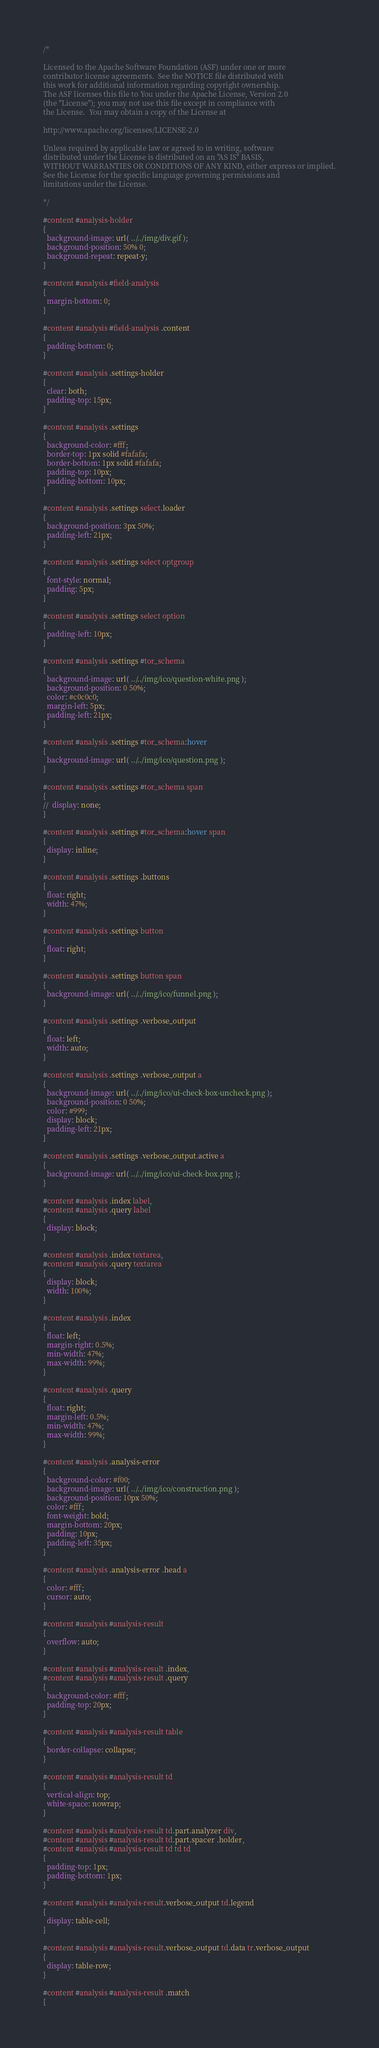<code> <loc_0><loc_0><loc_500><loc_500><_CSS_>/*

Licensed to the Apache Software Foundation (ASF) under one or more
contributor license agreements.  See the NOTICE file distributed with
this work for additional information regarding copyright ownership.
The ASF licenses this file to You under the Apache License, Version 2.0
(the "License"); you may not use this file except in compliance with
the License.  You may obtain a copy of the License at

http://www.apache.org/licenses/LICENSE-2.0

Unless required by applicable law or agreed to in writing, software
distributed under the License is distributed on an "AS IS" BASIS,
WITHOUT WARRANTIES OR CONDITIONS OF ANY KIND, either express or implied.
See the License for the specific language governing permissions and
limitations under the License.

*/

#content #analysis-holder
{
  background-image: url( ../../img/div.gif );
  background-position: 50% 0;
  background-repeat: repeat-y;
}

#content #analysis #field-analysis
{
  margin-bottom: 0;
}

#content #analysis #field-analysis .content
{
  padding-bottom: 0;
}

#content #analysis .settings-holder
{
  clear: both;
  padding-top: 15px;
}

#content #analysis .settings
{
  background-color: #fff;
  border-top: 1px solid #fafafa;
  border-bottom: 1px solid #fafafa;
  padding-top: 10px;
  padding-bottom: 10px;
}

#content #analysis .settings select.loader
{
  background-position: 3px 50%;
  padding-left: 21px;
}

#content #analysis .settings select optgroup
{
  font-style: normal;
  padding: 5px;
}

#content #analysis .settings select option
{
  padding-left: 10px;
}

#content #analysis .settings #tor_schema
{
  background-image: url( ../../img/ico/question-white.png );
  background-position: 0 50%;
  color: #c0c0c0;
  margin-left: 5px;
  padding-left: 21px;
}

#content #analysis .settings #tor_schema:hover
{
  background-image: url( ../../img/ico/question.png );
}

#content #analysis .settings #tor_schema span
{
//  display: none;
}

#content #analysis .settings #tor_schema:hover span
{
  display: inline;
}

#content #analysis .settings .buttons
{
  float: right;
  width: 47%;
}

#content #analysis .settings button
{
  float: right;
}

#content #analysis .settings button span
{
  background-image: url( ../../img/ico/funnel.png );
}

#content #analysis .settings .verbose_output
{
  float: left;
  width: auto;
}

#content #analysis .settings .verbose_output a
{
  background-image: url( ../../img/ico/ui-check-box-uncheck.png );
  background-position: 0 50%;
  color: #999;
  display: block;
  padding-left: 21px;
}

#content #analysis .settings .verbose_output.active a
{
  background-image: url( ../../img/ico/ui-check-box.png );
}

#content #analysis .index label,
#content #analysis .query label
{
  display: block;
}

#content #analysis .index textarea,
#content #analysis .query textarea
{
  display: block;
  width: 100%;
}

#content #analysis .index
{
  float: left;
  margin-right: 0.5%;
  min-width: 47%;
  max-width: 99%;
}

#content #analysis .query
{
  float: right;
  margin-left: 0.5%;
  min-width: 47%;
  max-width: 99%;
}

#content #analysis .analysis-error
{
  background-color: #f00;
  background-image: url( ../../img/ico/construction.png );
  background-position: 10px 50%;
  color: #fff;
  font-weight: bold;
  margin-bottom: 20px;
  padding: 10px;
  padding-left: 35px;
}

#content #analysis .analysis-error .head a
{
  color: #fff;
  cursor: auto;
}

#content #analysis #analysis-result
{
  overflow: auto;
}

#content #analysis #analysis-result .index,
#content #analysis #analysis-result .query
{
  background-color: #fff;
  padding-top: 20px;
}

#content #analysis #analysis-result table
{
  border-collapse: collapse;
}

#content #analysis #analysis-result td
{
  vertical-align: top;
  white-space: nowrap;
}

#content #analysis #analysis-result td.part.analyzer div,
#content #analysis #analysis-result td.part.spacer .holder,
#content #analysis #analysis-result td td td
{
  padding-top: 1px;
  padding-bottom: 1px;
}

#content #analysis #analysis-result.verbose_output td.legend
{
  display: table-cell;
}

#content #analysis #analysis-result.verbose_output td.data tr.verbose_output
{
  display: table-row;
}

#content #analysis #analysis-result .match
{</code> 